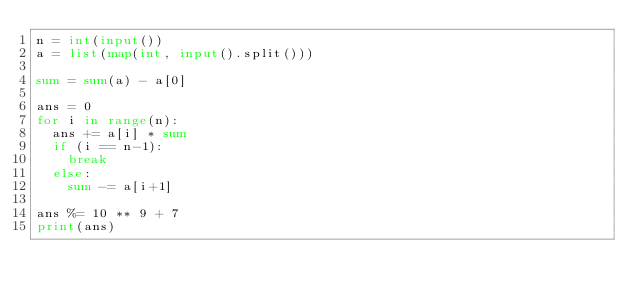<code> <loc_0><loc_0><loc_500><loc_500><_Python_>n = int(input())
a = list(map(int, input().split()))

sum = sum(a) - a[0]

ans = 0
for i in range(n):
  ans += a[i] * sum
  if (i == n-1):
    break
  else:
  	sum -= a[i+1]
  
ans %= 10 ** 9 + 7  
print(ans)</code> 